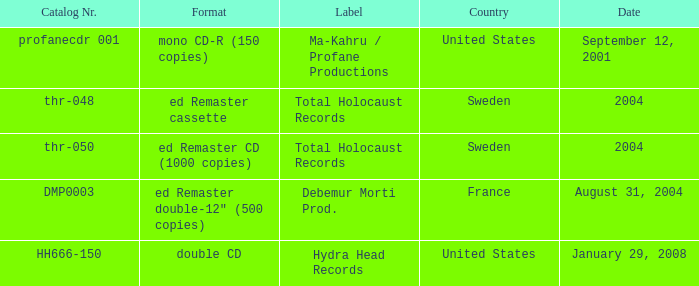What country is the Debemur Morti prod. label from? France. 